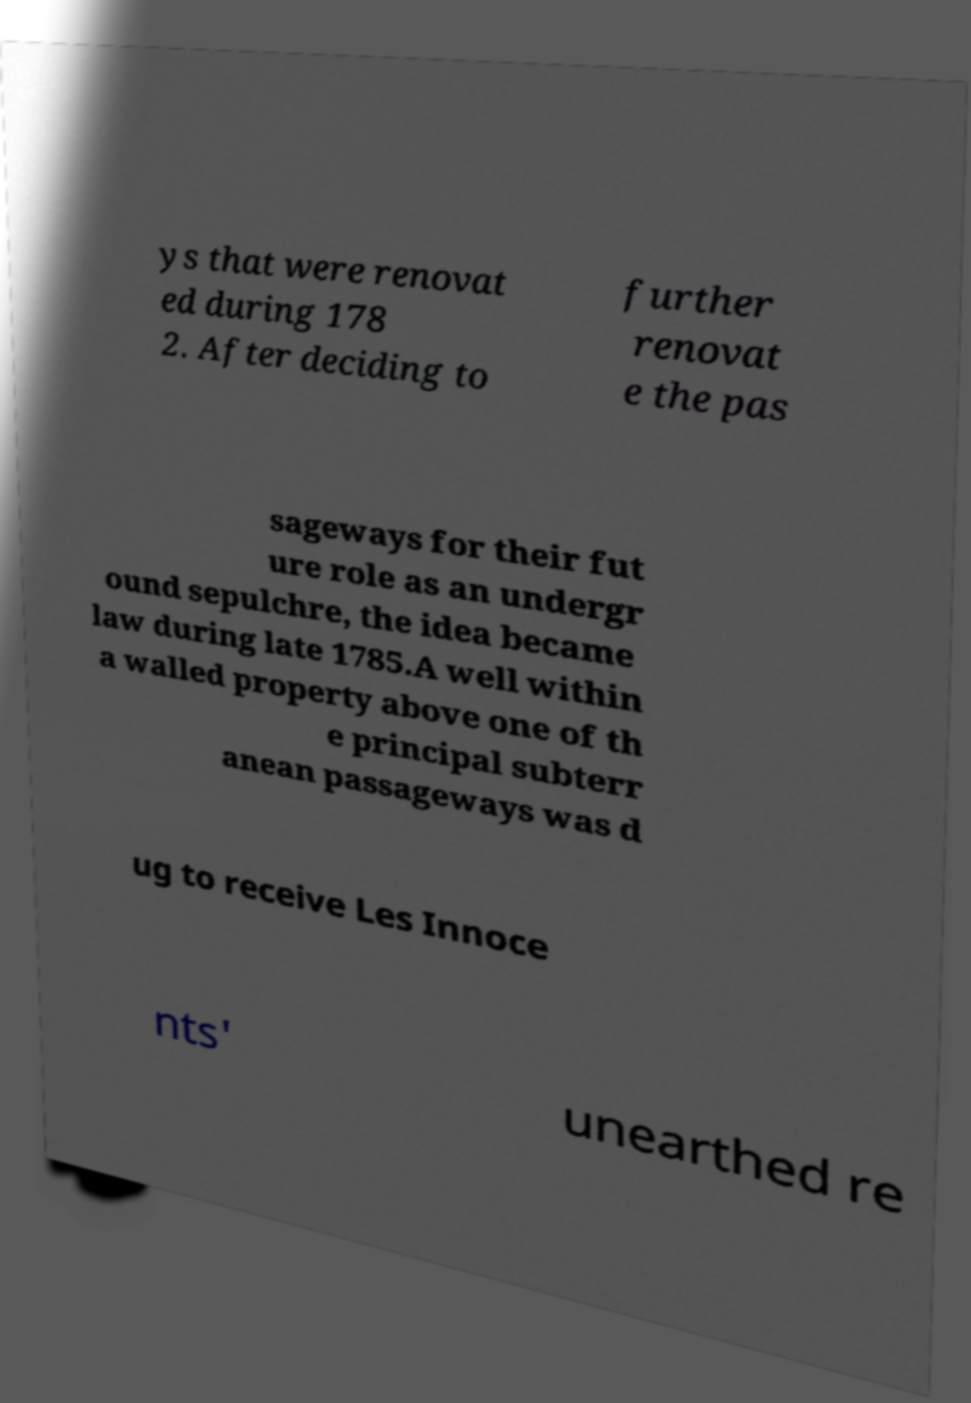There's text embedded in this image that I need extracted. Can you transcribe it verbatim? ys that were renovat ed during 178 2. After deciding to further renovat e the pas sageways for their fut ure role as an undergr ound sepulchre, the idea became law during late 1785.A well within a walled property above one of th e principal subterr anean passageways was d ug to receive Les Innoce nts' unearthed re 